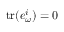Convert formula to latex. <formula><loc_0><loc_0><loc_500><loc_500>t r ( e _ { \omega } ^ { i } ) = 0</formula> 